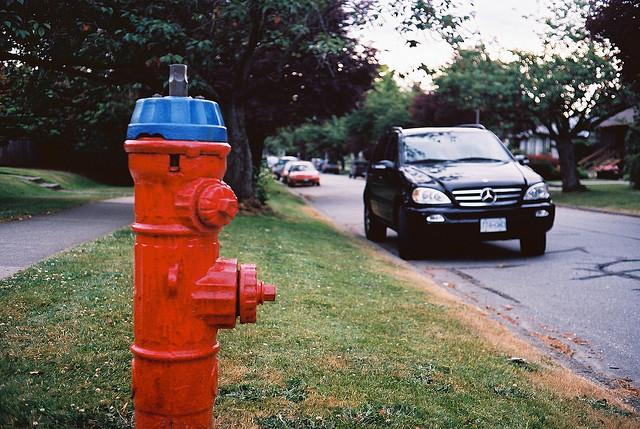Why is the black vehicle stopped near the curb? Please explain your reasoning. to park. He is stopped next to the curb to do so. 